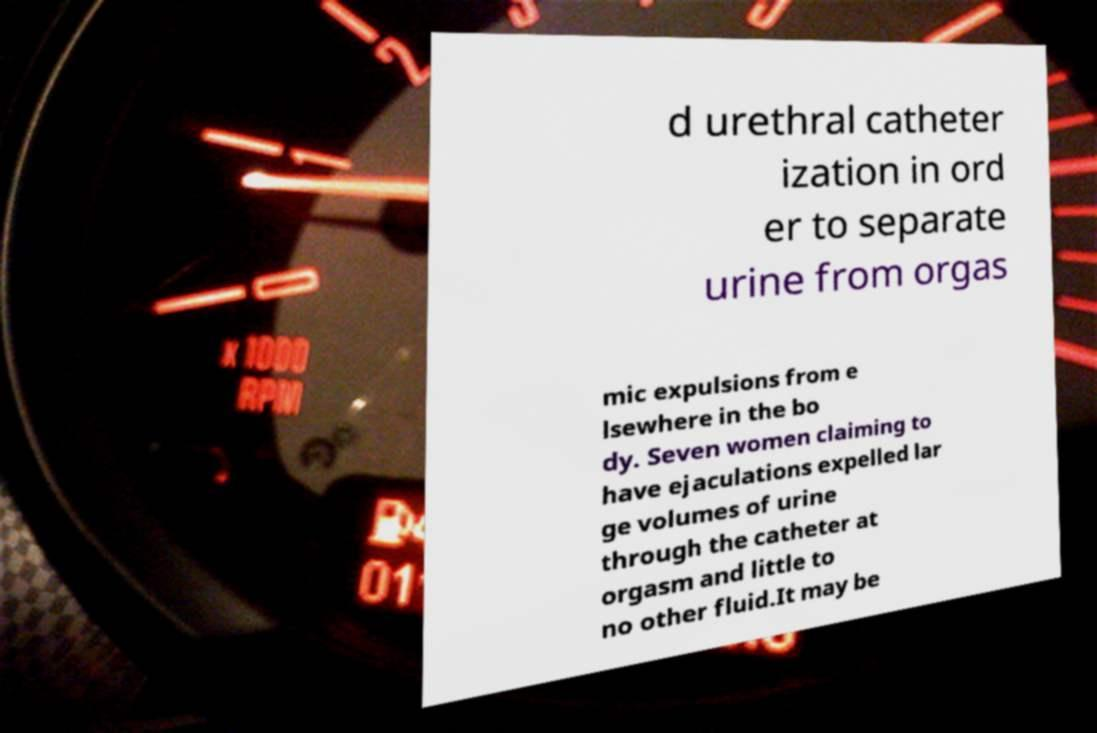For documentation purposes, I need the text within this image transcribed. Could you provide that? d urethral catheter ization in ord er to separate urine from orgas mic expulsions from e lsewhere in the bo dy. Seven women claiming to have ejaculations expelled lar ge volumes of urine through the catheter at orgasm and little to no other fluid.It may be 